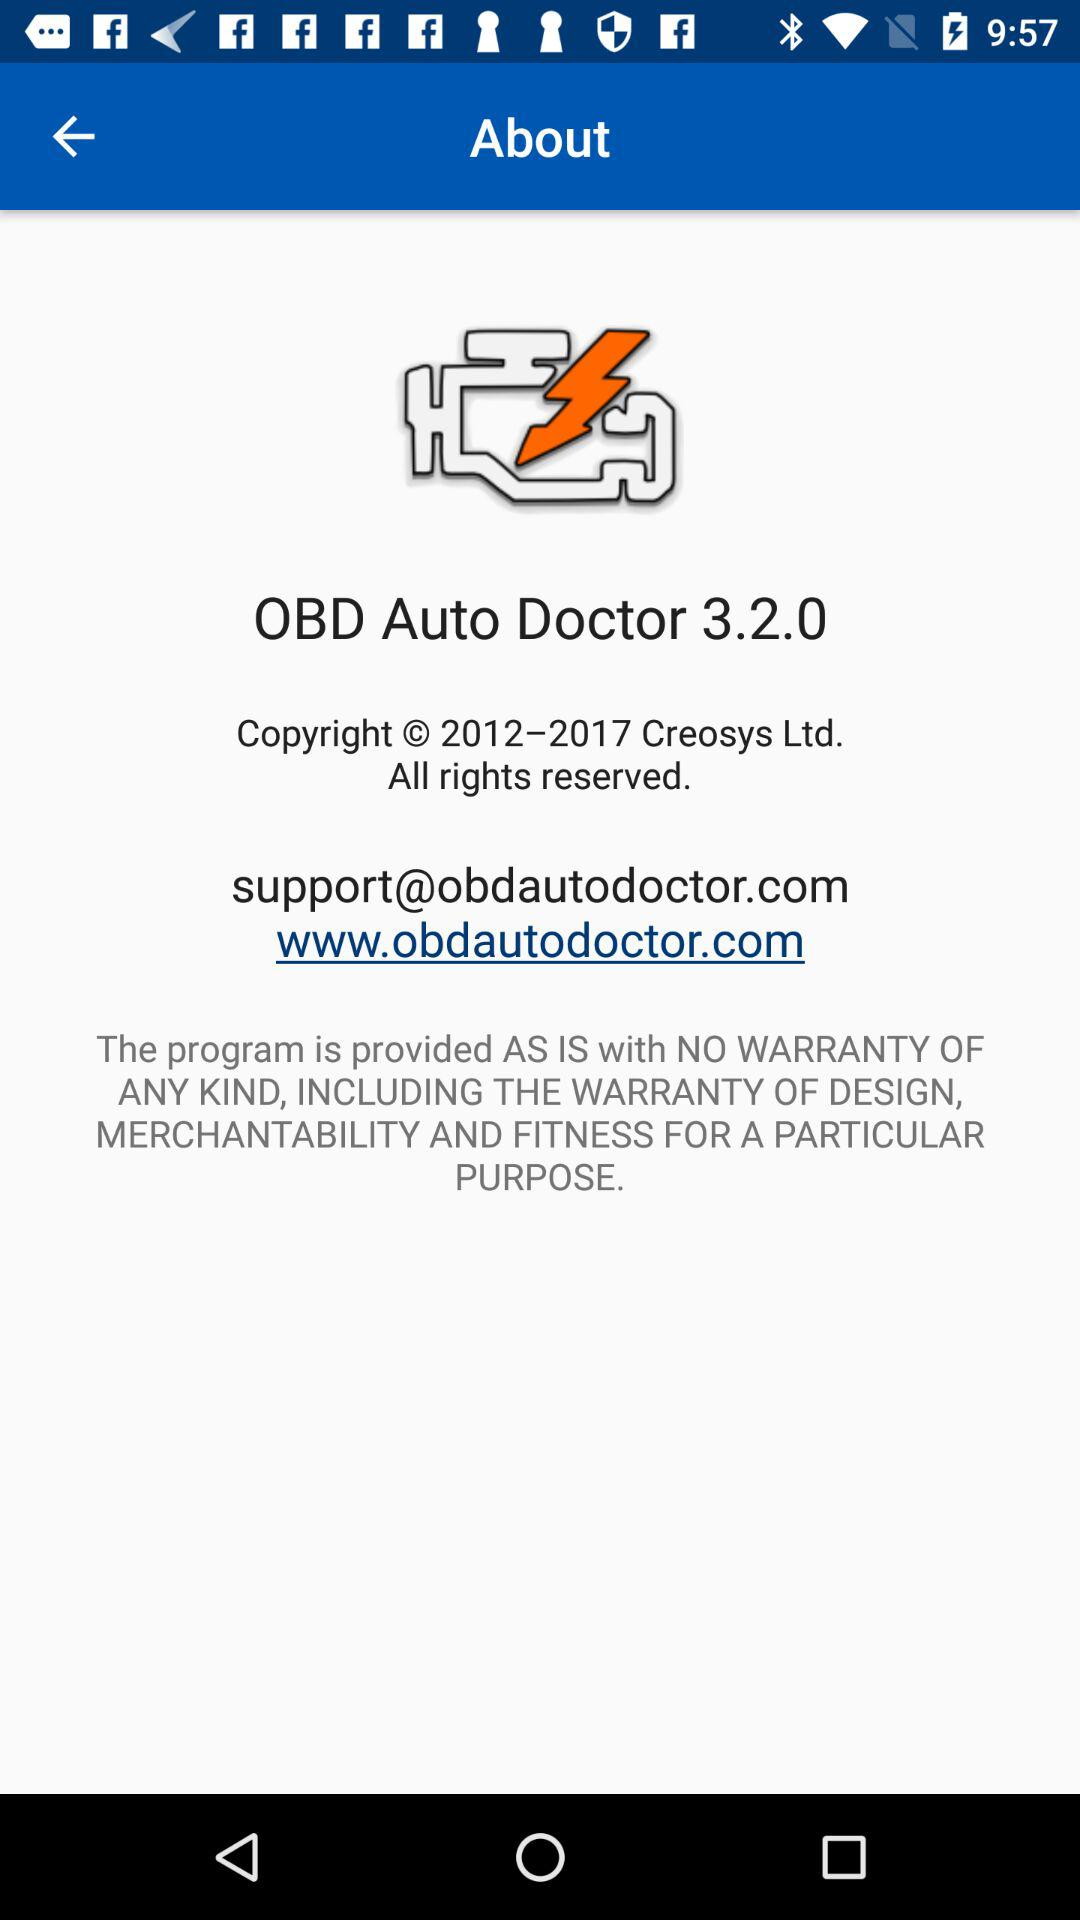Which version of "OBD Auto Doctor" is used? The used version is 3.2.0. 